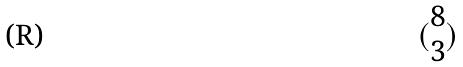<formula> <loc_0><loc_0><loc_500><loc_500>( \begin{matrix} 8 \\ 3 \end{matrix} )</formula> 